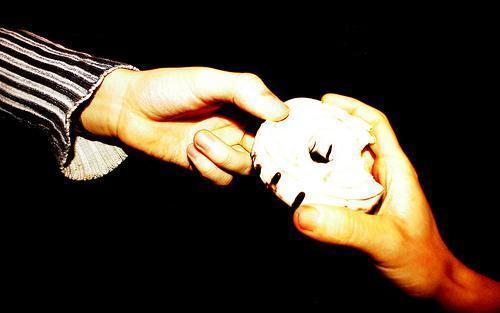How many hands are pictured?
Give a very brief answer. 2. 